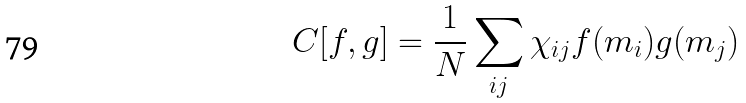<formula> <loc_0><loc_0><loc_500><loc_500>C [ f , g ] = \frac { 1 } { N } \sum _ { i j } \chi _ { i j } f ( m _ { i } ) g ( m _ { j } )</formula> 